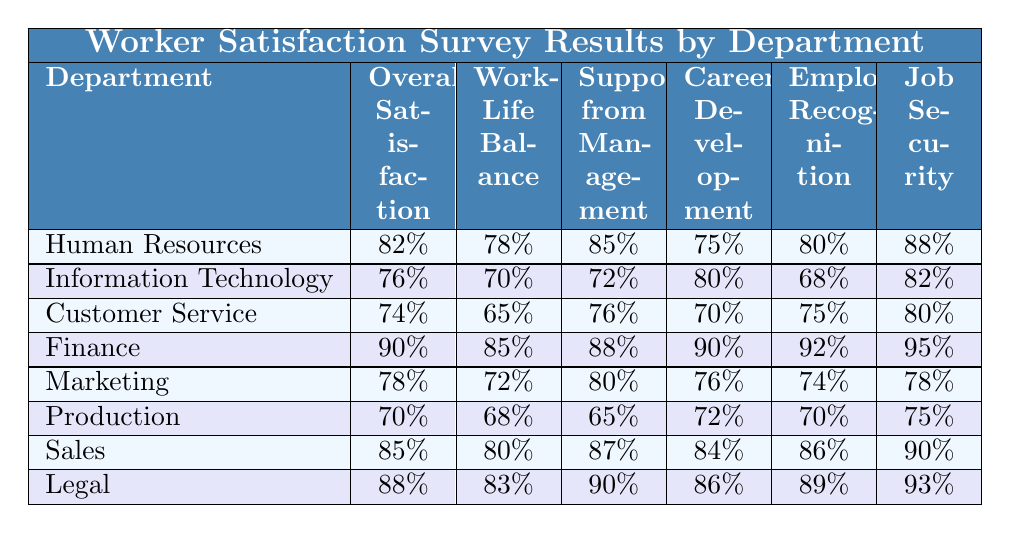What is the overall satisfaction score for the Finance department? The table shows that the Finance department has an Overall Satisfaction score of 90%.
Answer: 90% Which department has the highest score for Job Security? Looking at the table, Finance has the highest Job Security score of 95%.
Answer: Finance What is the average Work-Life Balance score across all departments? The Work-Life Balance scores are 78, 70, 65, 85, 72, 68, 80, and 83. Summing these gives 585. Dividing by 8 yields an average of 73.125.
Answer: 73.125 Is the Support from Management score for Sales higher than that for Information Technology? Sales has a Support from Management score of 87%, and Information Technology has a score of 72%. Since 87 is greater than 72, the statement is true.
Answer: Yes Which department has the lowest Employee Recognition score? Customer Service has an Employee Recognition score of 75%, which is lower than those of all other departments.
Answer: Customer Service What is the difference in overall satisfaction between the Legal and Production departments? Legal has an Overall Satisfaction score of 88%, while Production has a score of 70%. The difference is 88 - 70 = 18.
Answer: 18 Which department shows the greatest disparity between Work-Life Balance and Overall Satisfaction? For each department, we calculate the difference: Human Resources (4), Information Technology (6), Customer Service (9), Finance (5), Marketing (6), Production (2), Sales (5), and Legal (5). Customer Service shows the greatest disparity with 9.
Answer: Customer Service How do the Career Development Opportunities scores compare for HR and Marketing? HR has a Career Development Opportunities score of 75% and Marketing has a score of 76%. Since 76 is greater than 75, Marketing has a superior score.
Answer: Marketing Which departments have an Overall Satisfaction score above 80%? Checking the table, Human Resources (82%), Finance (90%), Sales (85%), and Legal (88%) all have scores above 80%.
Answer: Human Resources, Finance, Sales, Legal Is there any department where all satisfaction criteria are above 80%? Looking closely, the Finance department has scores above 80% for Overall Satisfaction (90%), Work-Life Balance (85%), Support from Management (88%), Career Development (90%), Employee Recognition (92%), and Job Security (95%). Therefore, the answer is yes.
Answer: Yes 